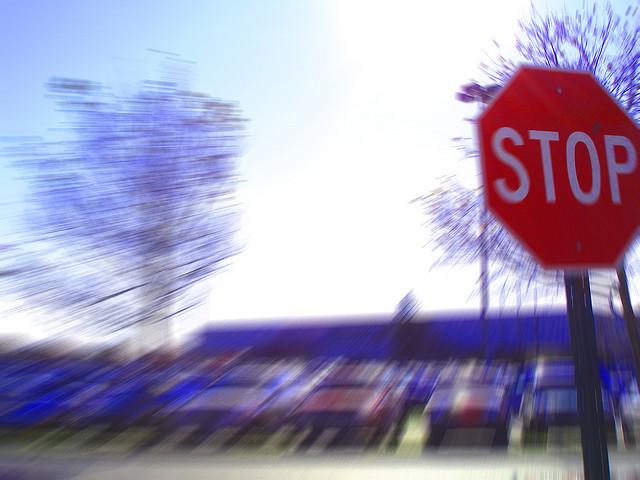What does the sign say?
Answer briefly. Stop. What color is the sign?
Quick response, please. Red. Is the photo blurred?
Write a very short answer. Yes. 